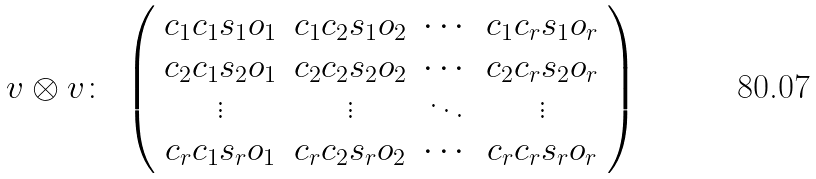Convert formula to latex. <formula><loc_0><loc_0><loc_500><loc_500>v \otimes v \colon \ \left ( \begin{array} { c c c c c } c _ { 1 } c _ { 1 } s _ { 1 } o _ { 1 } & c _ { 1 } c _ { 2 } s _ { 1 } o _ { 2 } & \cdots & c _ { 1 } c _ { r } s _ { 1 } o _ { r } \\ c _ { 2 } c _ { 1 } s _ { 2 } o _ { 1 } & c _ { 2 } c _ { 2 } s _ { 2 } o _ { 2 } & \cdots & c _ { 2 } c _ { r } s _ { 2 } o _ { r } \\ \vdots & \vdots & \ddots & \vdots \\ c _ { r } c _ { 1 } s _ { r } o _ { 1 } & c _ { r } c _ { 2 } s _ { r } o _ { 2 } & \cdots & c _ { r } c _ { r } s _ { r } o _ { r } \end{array} \right )</formula> 